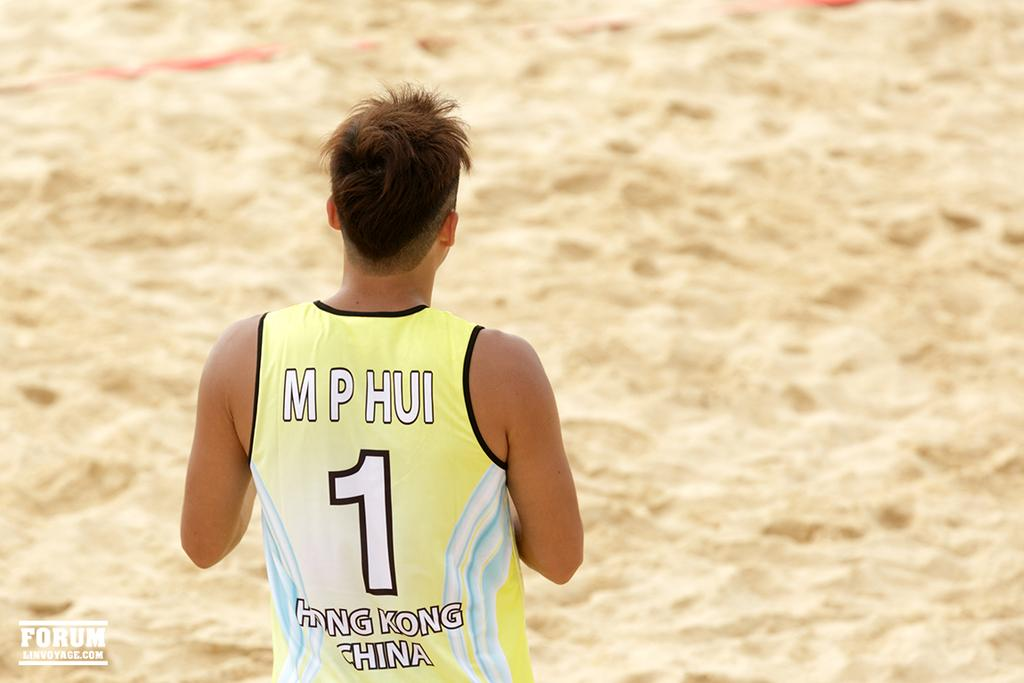<image>
Give a short and clear explanation of the subsequent image. Guy with a yellow jersey for hong kong china is standing on sand 